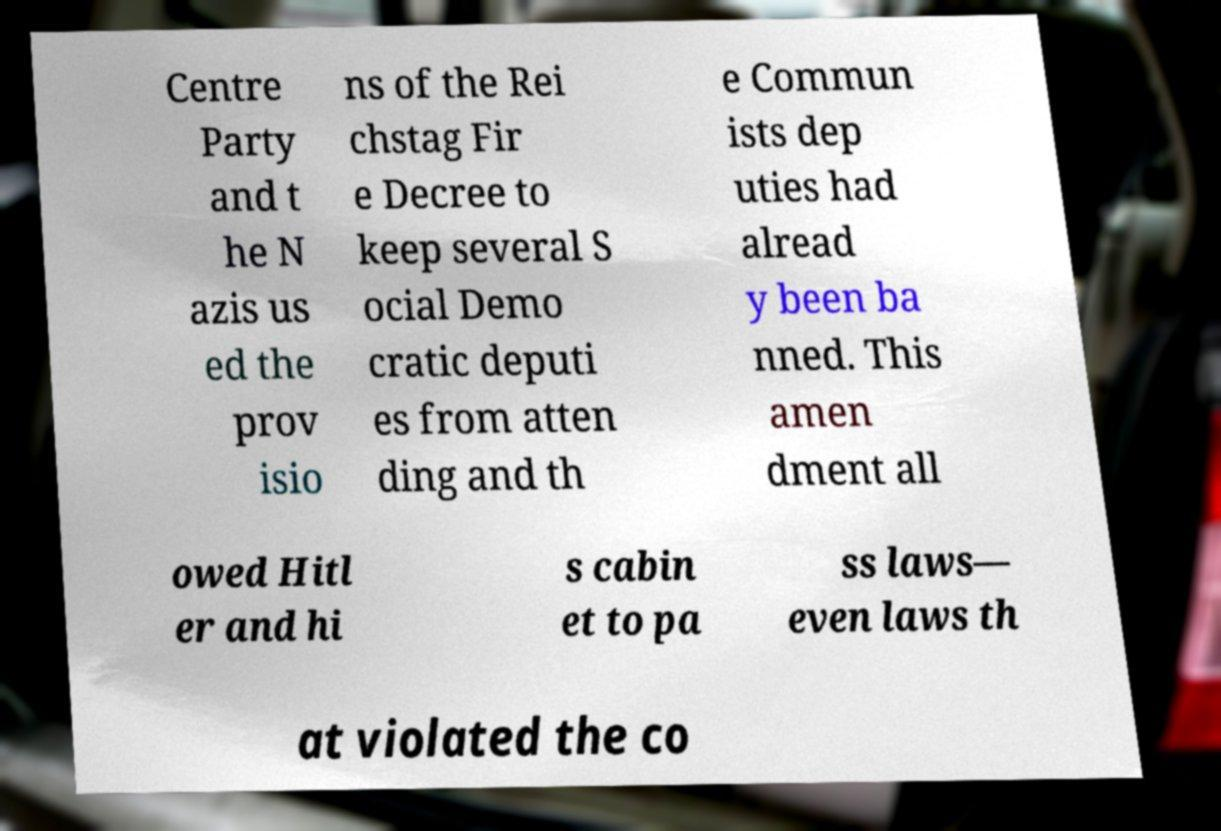Please read and relay the text visible in this image. What does it say? Centre Party and t he N azis us ed the prov isio ns of the Rei chstag Fir e Decree to keep several S ocial Demo cratic deputi es from atten ding and th e Commun ists dep uties had alread y been ba nned. This amen dment all owed Hitl er and hi s cabin et to pa ss laws— even laws th at violated the co 